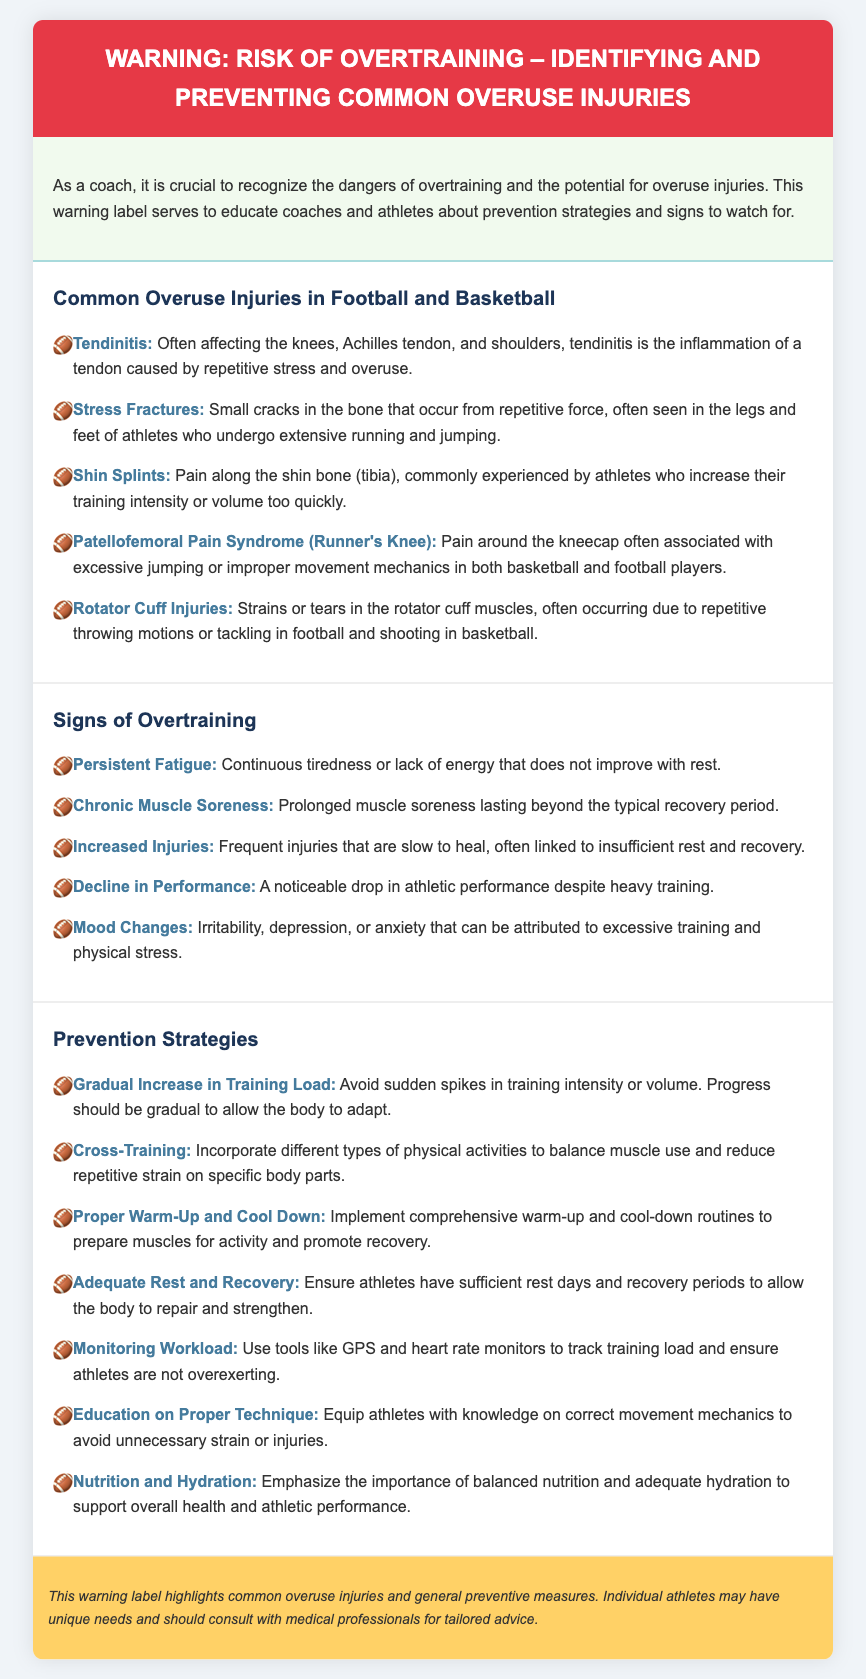What is the title of the warning label? The title of the warning label is explicitly stated at the top of the document.
Answer: WARNING: Risk of Overtraining – Identifying and Preventing Common Overuse Injuries How many common overuse injuries are listed? The document enumerates several injuries, which can be counted from the list presented.
Answer: Five What is a common sign of overtraining? The document highlights various signs; one can be cited directly from the signs section.
Answer: Persistent Fatigue What strategy can help prevent overuse injuries? The prevention strategies section contains multiple strategies; one can be chosen as an example.
Answer: Gradual Increase in Training Load What type of injury is associated with excessive jumping? The document specifies a particular injury connected to jumping activities under the common overuse injuries section.
Answer: Patellofemoral Pain Syndrome (Runner's Knee) What is one example of a psychological sign of overtraining? The signs of overtraining include emotional symptoms, one of which can be directly referenced.
Answer: Mood Changes What should athletes focus on for overall health and performance? The document discusses elements critical to health and performance and emphasizes one specifically.
Answer: Nutrition and Hydration What is the injury type caused by repetitive stress on tendons? The document provides specific conditions due to repetitive stress; one is explicitly mentioned.
Answer: Tendinitis 